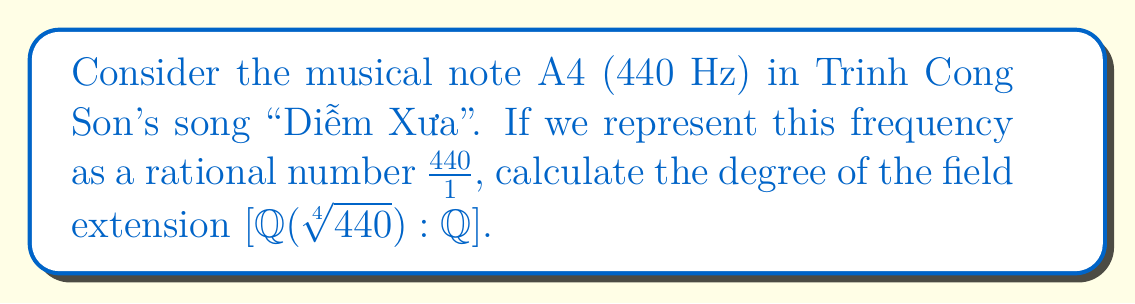Give your solution to this math problem. To solve this problem, we'll follow these steps:

1) First, we need to determine if $\sqrt[4]{440}$ is algebraic over $\mathbb{Q}$. Since it's the root of a polynomial with rational coefficients ($x^4 - 440 = 0$), it is indeed algebraic.

2) Now, we need to find the minimal polynomial of $\sqrt[4]{440}$ over $\mathbb{Q}$. Let $\alpha = \sqrt[4]{440}$. Then $\alpha^4 = 440$.

3) The polynomial $x^4 - 440$ is irreducible over $\mathbb{Q}$ by Eisenstein's criterion with prime $p=2$ (note that $440 = 2^3 \cdot 5 \cdot 11$).

4) Since $x^4 - 440$ is the minimal polynomial of $\alpha$ over $\mathbb{Q}$, its degree is 4.

5) The degree of the field extension is equal to the degree of the minimal polynomial. Therefore:

   $[\mathbb{Q}(\sqrt[4]{440}):\mathbb{Q}] = 4$

This means that $\mathbb{Q}(\sqrt[4]{440})$ is a 4-dimensional vector space over $\mathbb{Q}$, with basis $\{1, \sqrt[4]{440}, \sqrt[2]{440}, \sqrt[4]{440^3}\}$.
Answer: $4$ 